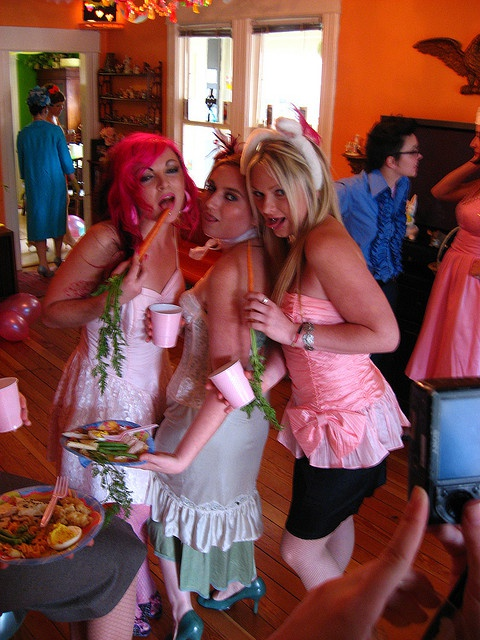Describe the objects in this image and their specific colors. I can see people in maroon, brown, black, and pink tones, people in maroon, brown, and black tones, people in maroon, darkgray, brown, and gray tones, people in maroon, black, and gray tones, and people in maroon, brown, and black tones in this image. 